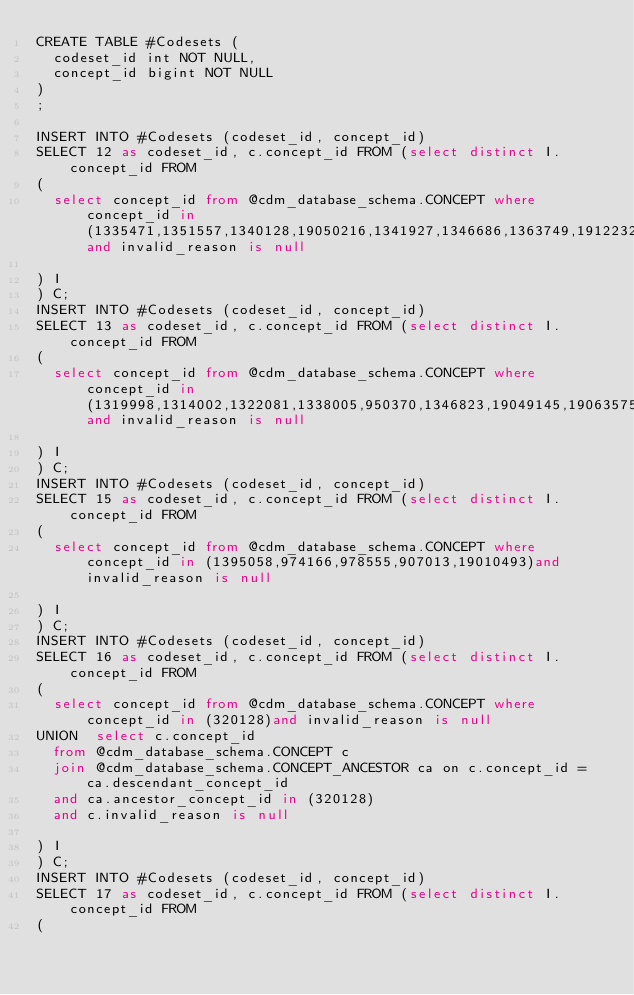<code> <loc_0><loc_0><loc_500><loc_500><_SQL_>CREATE TABLE #Codesets (
  codeset_id int NOT NULL,
  concept_id bigint NOT NULL
)
;

INSERT INTO #Codesets (codeset_id, concept_id)
SELECT 12 as codeset_id, c.concept_id FROM (select distinct I.concept_id FROM
( 
  select concept_id from @cdm_database_schema.CONCEPT where concept_id in (1335471,1351557,1340128,19050216,1341927,1346686,1363749,19122327,1347384,1308216,1367500,1310756,40226742,1373225,1331235,1334456,1317640,1308842,19102107)and invalid_reason is null

) I
) C;
INSERT INTO #Codesets (codeset_id, concept_id)
SELECT 13 as codeset_id, c.concept_id FROM (select distinct I.concept_id FROM
( 
  select concept_id from @cdm_database_schema.CONCEPT where concept_id in (1319998,1314002,1322081,1338005,950370,1346823,19049145,19063575,1386957,1307046,1314577,19024904,1327978,1345858,1353766)and invalid_reason is null

) I
) C;
INSERT INTO #Codesets (codeset_id, concept_id)
SELECT 15 as codeset_id, c.concept_id FROM (select distinct I.concept_id FROM
( 
  select concept_id from @cdm_database_schema.CONCEPT where concept_id in (1395058,974166,978555,907013,19010493)and invalid_reason is null

) I
) C;
INSERT INTO #Codesets (codeset_id, concept_id)
SELECT 16 as codeset_id, c.concept_id FROM (select distinct I.concept_id FROM
( 
  select concept_id from @cdm_database_schema.CONCEPT where concept_id in (320128)and invalid_reason is null
UNION  select c.concept_id
  from @cdm_database_schema.CONCEPT c
  join @cdm_database_schema.CONCEPT_ANCESTOR ca on c.concept_id = ca.descendant_concept_id
  and ca.ancestor_concept_id in (320128)
  and c.invalid_reason is null

) I
) C;
INSERT INTO #Codesets (codeset_id, concept_id)
SELECT 17 as codeset_id, c.concept_id FROM (select distinct I.concept_id FROM
( </code> 